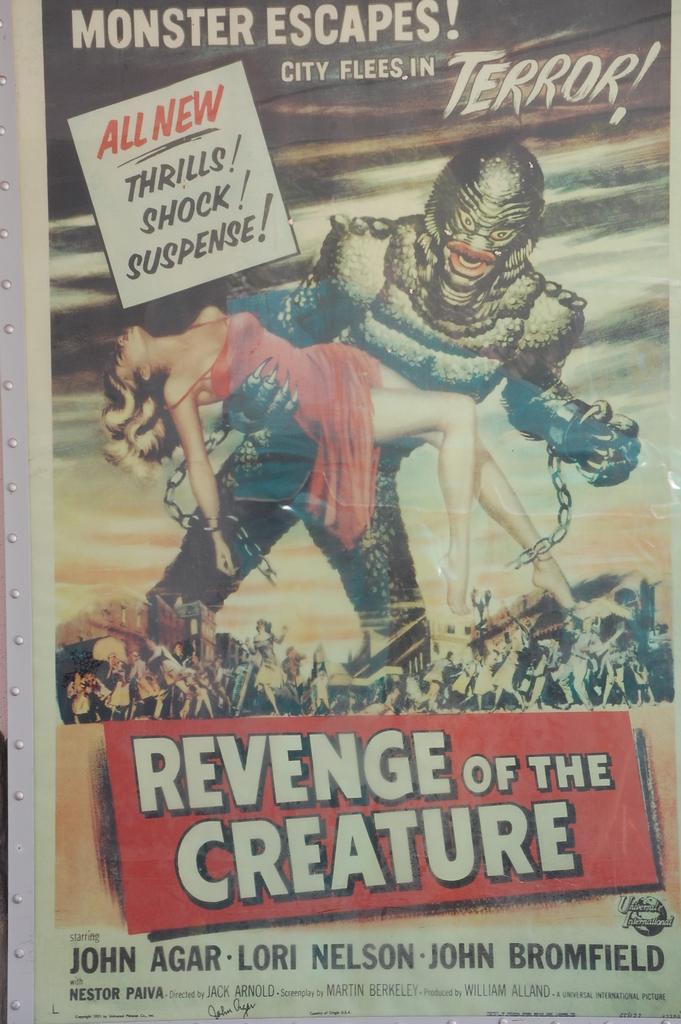Revenge of the what?
Your answer should be very brief. Creature. Who is the author?
Provide a short and direct response. John agar. 